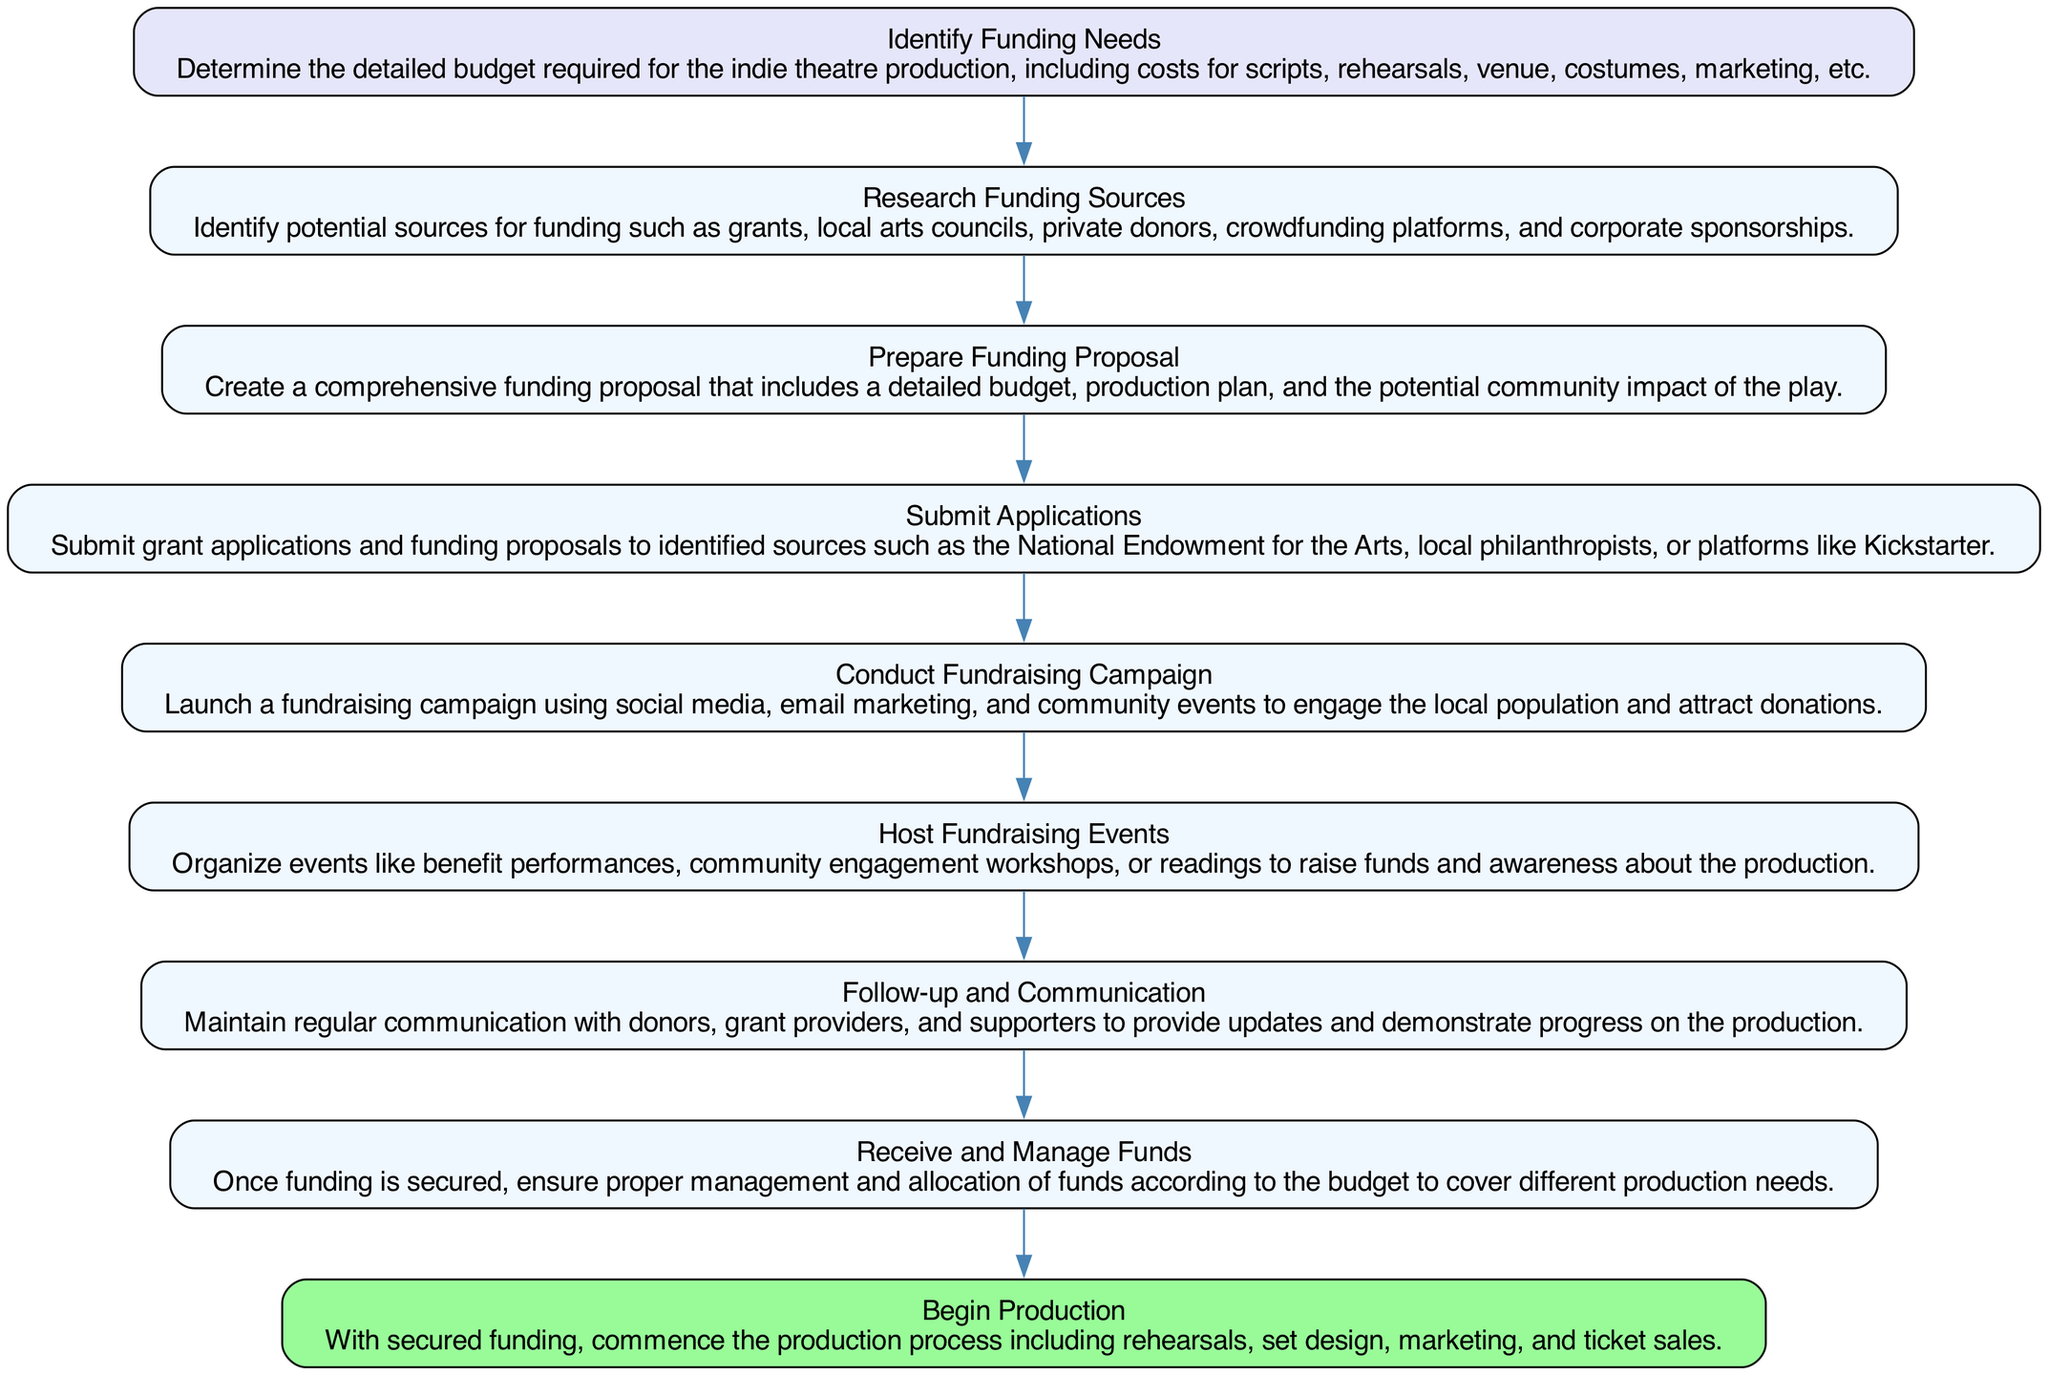What is the first step in the funding process? The first step in the funding process according to the diagram is "Identify Funding Needs." This node is positioned at the top of the flow, indicating it is the starting point of the sequence.
Answer: Identify Funding Needs How many nodes are present in the diagram? By counting each element in the list provided within the diagram data, we can see there are nine distinct nodes representing each step in the funding process.
Answer: Nine What action follows submission of applications? After "Submit Applications," the next action in the process is "Conduct Fundraising Campaign." This is determined by examining the flow of arrows indicating the sequence of steps.
Answer: Conduct Fundraising Campaign Which step involves creating a proposal focused on community impact? The step that includes creating a proposal focused on community impact is "Prepare Funding Proposal." This node mentions the importance of including the potential community impact in the proposal details.
Answer: Prepare Funding Proposal What is the final step in securing funding for an indie theatre production? The last step in the diagram is "Begin Production." This represents the conclusion of the funding process where actual work on the production commences after securing funds.
Answer: Begin Production What is required after funds are received? After the funds are received, the step is "Receive and Manage Funds." This node indicates the need for proper management and allocation of the received funds according to the planned budget.
Answer: Receive and Manage Funds How many fundraising events are suggested in the process? The diagram suggests organizing "Host Fundraising Events" as part of the fundraising strategy. This implies a need for multiple events rather than specifying a number. Thus, there can be various fundraising events based on this node's indication.
Answer: Multiple What action should be taken to maintain communication with supporters? The action to maintain communication with supporters is outlined in "Follow-up and Communication." This step emphasizes keeping donors updated and engaged throughout the process.
Answer: Follow-up and Communication Which step involves identifying private donors? The step involved in identifying private donors is "Research Funding Sources." This node mentions exploring various funding sources, including private donors among other options listed.
Answer: Research Funding Sources 